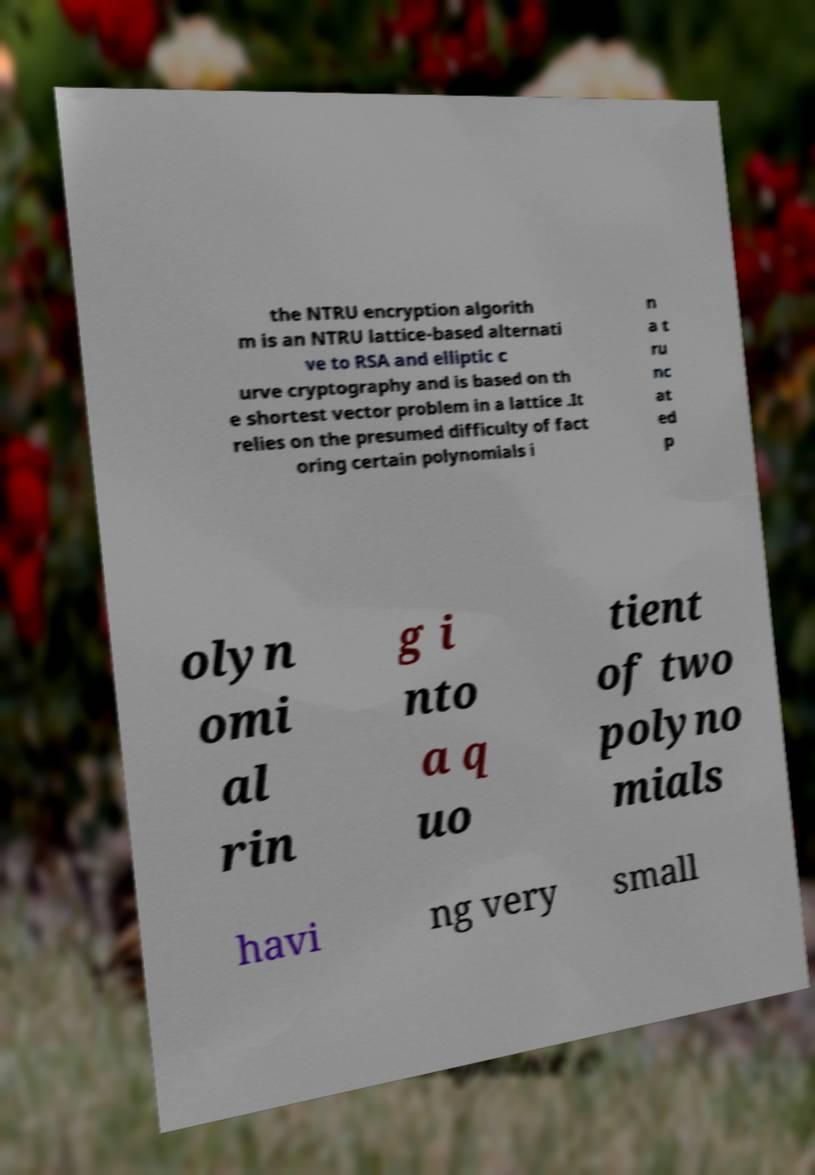Can you read and provide the text displayed in the image?This photo seems to have some interesting text. Can you extract and type it out for me? the NTRU encryption algorith m is an NTRU lattice-based alternati ve to RSA and elliptic c urve cryptography and is based on th e shortest vector problem in a lattice .It relies on the presumed difficulty of fact oring certain polynomials i n a t ru nc at ed p olyn omi al rin g i nto a q uo tient of two polyno mials havi ng very small 